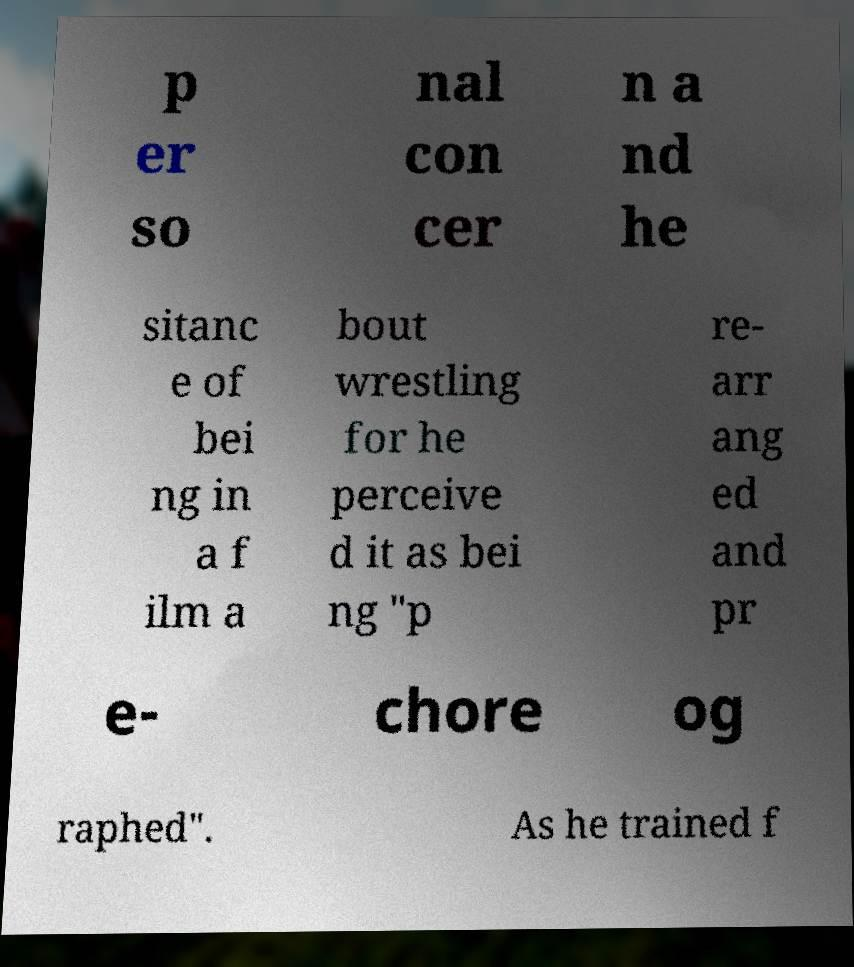Please identify and transcribe the text found in this image. p er so nal con cer n a nd he sitanc e of bei ng in a f ilm a bout wrestling for he perceive d it as bei ng "p re- arr ang ed and pr e- chore og raphed". As he trained f 